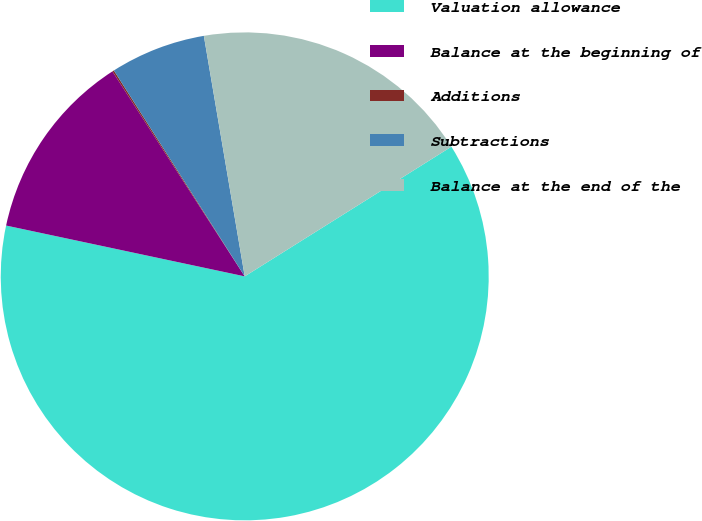<chart> <loc_0><loc_0><loc_500><loc_500><pie_chart><fcel>Valuation allowance<fcel>Balance at the beginning of<fcel>Additions<fcel>Subtractions<fcel>Balance at the end of the<nl><fcel>62.26%<fcel>12.54%<fcel>0.11%<fcel>6.33%<fcel>18.76%<nl></chart> 